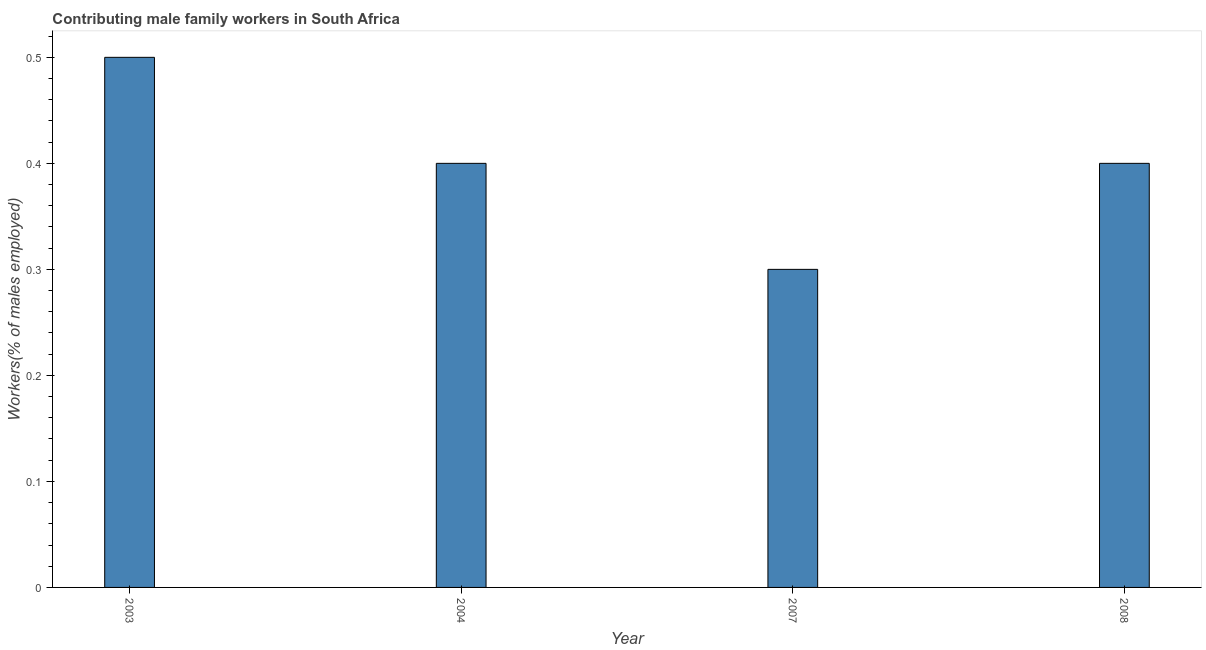Does the graph contain grids?
Make the answer very short. No. What is the title of the graph?
Give a very brief answer. Contributing male family workers in South Africa. What is the label or title of the Y-axis?
Your response must be concise. Workers(% of males employed). Across all years, what is the maximum contributing male family workers?
Your response must be concise. 0.5. Across all years, what is the minimum contributing male family workers?
Your answer should be compact. 0.3. In which year was the contributing male family workers maximum?
Your answer should be very brief. 2003. What is the sum of the contributing male family workers?
Provide a succinct answer. 1.6. What is the difference between the contributing male family workers in 2007 and 2008?
Keep it short and to the point. -0.1. What is the average contributing male family workers per year?
Your answer should be compact. 0.4. What is the median contributing male family workers?
Offer a very short reply. 0.4. In how many years, is the contributing male family workers greater than 0.04 %?
Make the answer very short. 4. Do a majority of the years between 2008 and 2004 (inclusive) have contributing male family workers greater than 0.26 %?
Offer a very short reply. Yes. What is the ratio of the contributing male family workers in 2004 to that in 2007?
Your answer should be compact. 1.33. Is the contributing male family workers in 2003 less than that in 2008?
Make the answer very short. No. What is the difference between the highest and the lowest contributing male family workers?
Your answer should be very brief. 0.2. How many bars are there?
Your answer should be compact. 4. What is the Workers(% of males employed) in 2004?
Offer a very short reply. 0.4. What is the Workers(% of males employed) in 2007?
Provide a short and direct response. 0.3. What is the Workers(% of males employed) in 2008?
Provide a short and direct response. 0.4. What is the difference between the Workers(% of males employed) in 2003 and 2007?
Offer a terse response. 0.2. What is the difference between the Workers(% of males employed) in 2003 and 2008?
Provide a short and direct response. 0.1. What is the difference between the Workers(% of males employed) in 2004 and 2008?
Offer a very short reply. 0. What is the ratio of the Workers(% of males employed) in 2003 to that in 2007?
Offer a very short reply. 1.67. What is the ratio of the Workers(% of males employed) in 2004 to that in 2007?
Keep it short and to the point. 1.33. What is the ratio of the Workers(% of males employed) in 2004 to that in 2008?
Your answer should be very brief. 1. What is the ratio of the Workers(% of males employed) in 2007 to that in 2008?
Keep it short and to the point. 0.75. 